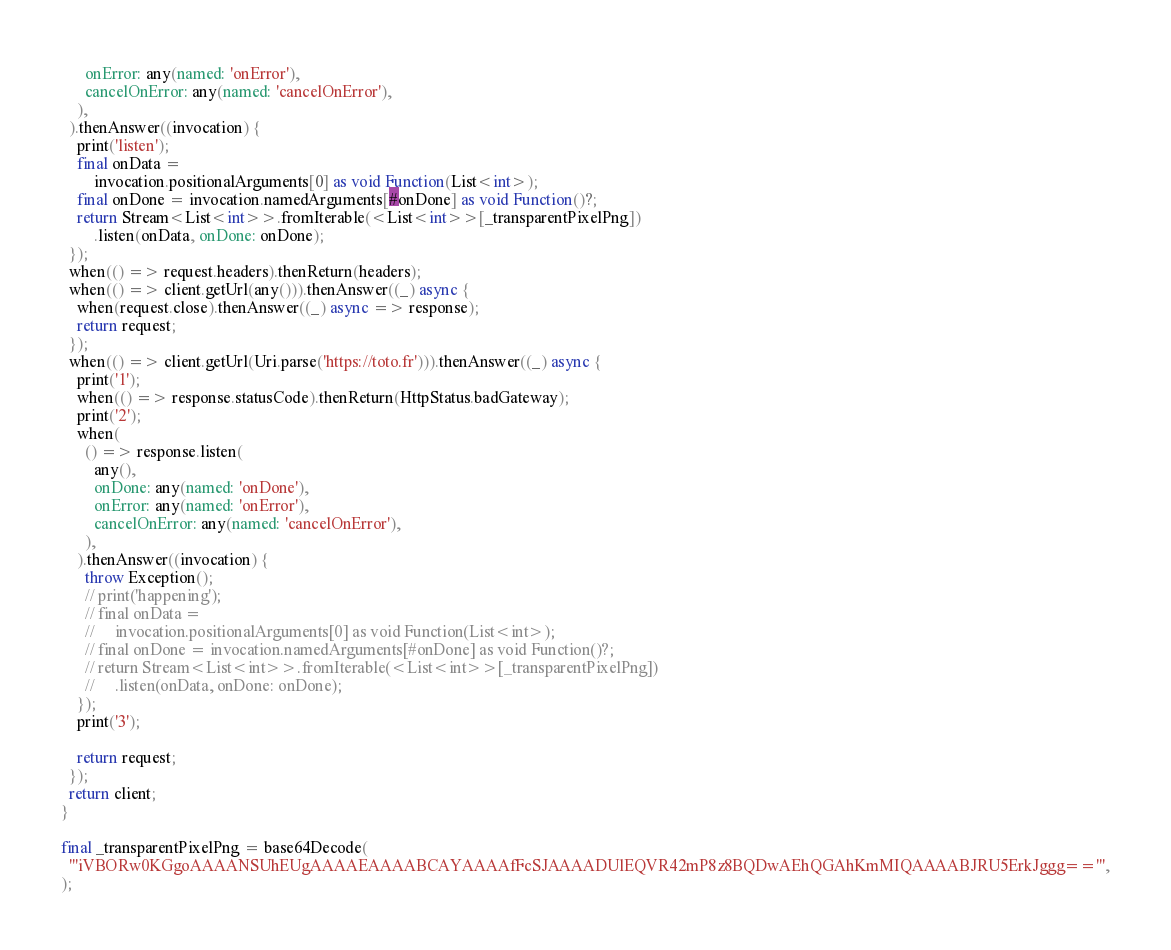<code> <loc_0><loc_0><loc_500><loc_500><_Dart_>      onError: any(named: 'onError'),
      cancelOnError: any(named: 'cancelOnError'),
    ),
  ).thenAnswer((invocation) {
    print('listen');
    final onData =
        invocation.positionalArguments[0] as void Function(List<int>);
    final onDone = invocation.namedArguments[#onDone] as void Function()?;
    return Stream<List<int>>.fromIterable(<List<int>>[_transparentPixelPng])
        .listen(onData, onDone: onDone);
  });
  when(() => request.headers).thenReturn(headers);
  when(() => client.getUrl(any())).thenAnswer((_) async {
    when(request.close).thenAnswer((_) async => response);
    return request;
  });
  when(() => client.getUrl(Uri.parse('https://toto.fr'))).thenAnswer((_) async {
    print('1');
    when(() => response.statusCode).thenReturn(HttpStatus.badGateway);
    print('2');
    when(
      () => response.listen(
        any(),
        onDone: any(named: 'onDone'),
        onError: any(named: 'onError'),
        cancelOnError: any(named: 'cancelOnError'),
      ),
    ).thenAnswer((invocation) {
      throw Exception();
      // print('happening');
      // final onData =
      //     invocation.positionalArguments[0] as void Function(List<int>);
      // final onDone = invocation.namedArguments[#onDone] as void Function()?;
      // return Stream<List<int>>.fromIterable(<List<int>>[_transparentPixelPng])
      //     .listen(onData, onDone: onDone);
    });
    print('3');

    return request;
  });
  return client;
}

final _transparentPixelPng = base64Decode(
  '''iVBORw0KGgoAAAANSUhEUgAAAAEAAAABCAYAAAAfFcSJAAAADUlEQVR42mP8z8BQDwAEhQGAhKmMIQAAAABJRU5ErkJggg==''',
);
</code> 